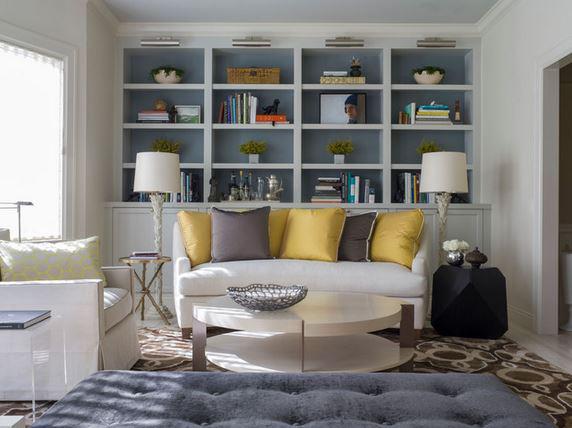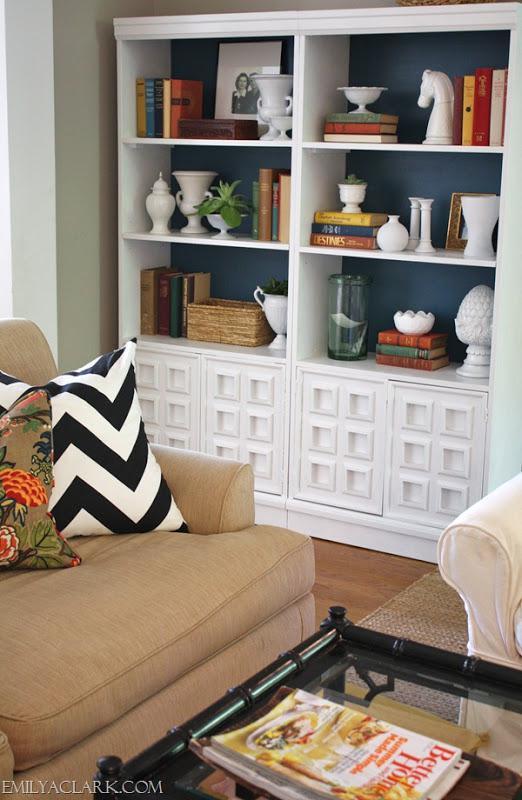The first image is the image on the left, the second image is the image on the right. Analyze the images presented: Is the assertion "In one image, white shelving units, in a room with a sofa, chair and coffee table, have four levels of upper shelves and solid panel doors below." valid? Answer yes or no. Yes. 